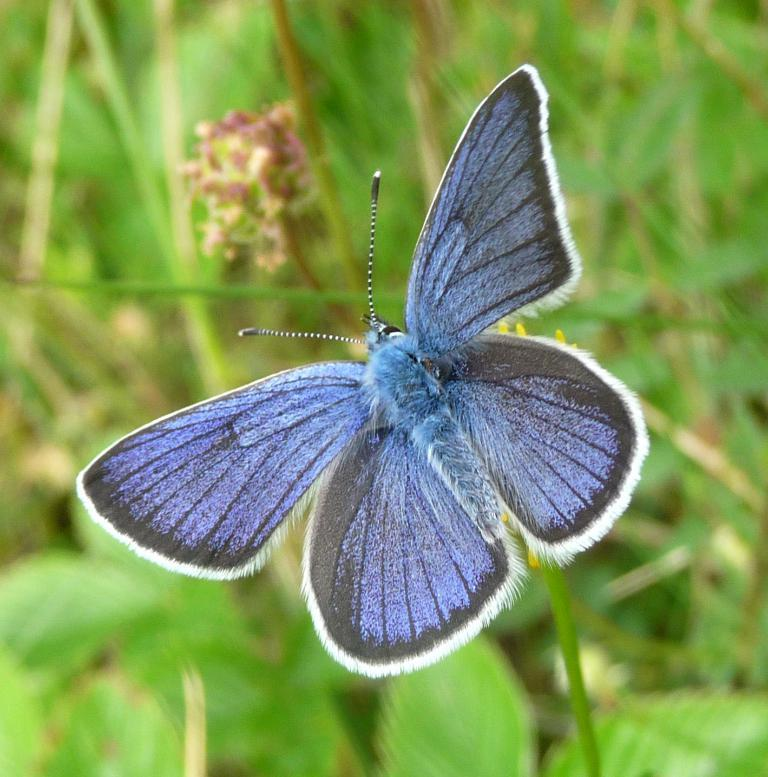What type of insect is in the image? There is a blue color butterfly in the image. What is the butterfly resting on? The butterfly is on a yellow color flower. What can be seen in the background of the image? There are plants in the background of the image. What is the color of the plants in the background? The plants are green in color. How is the background of the image depicted? The background is blurred. What type of curtain can be seen in the image? There is no curtain present in the image; it features a blue butterfly on a yellow flower with green plants in the background. 